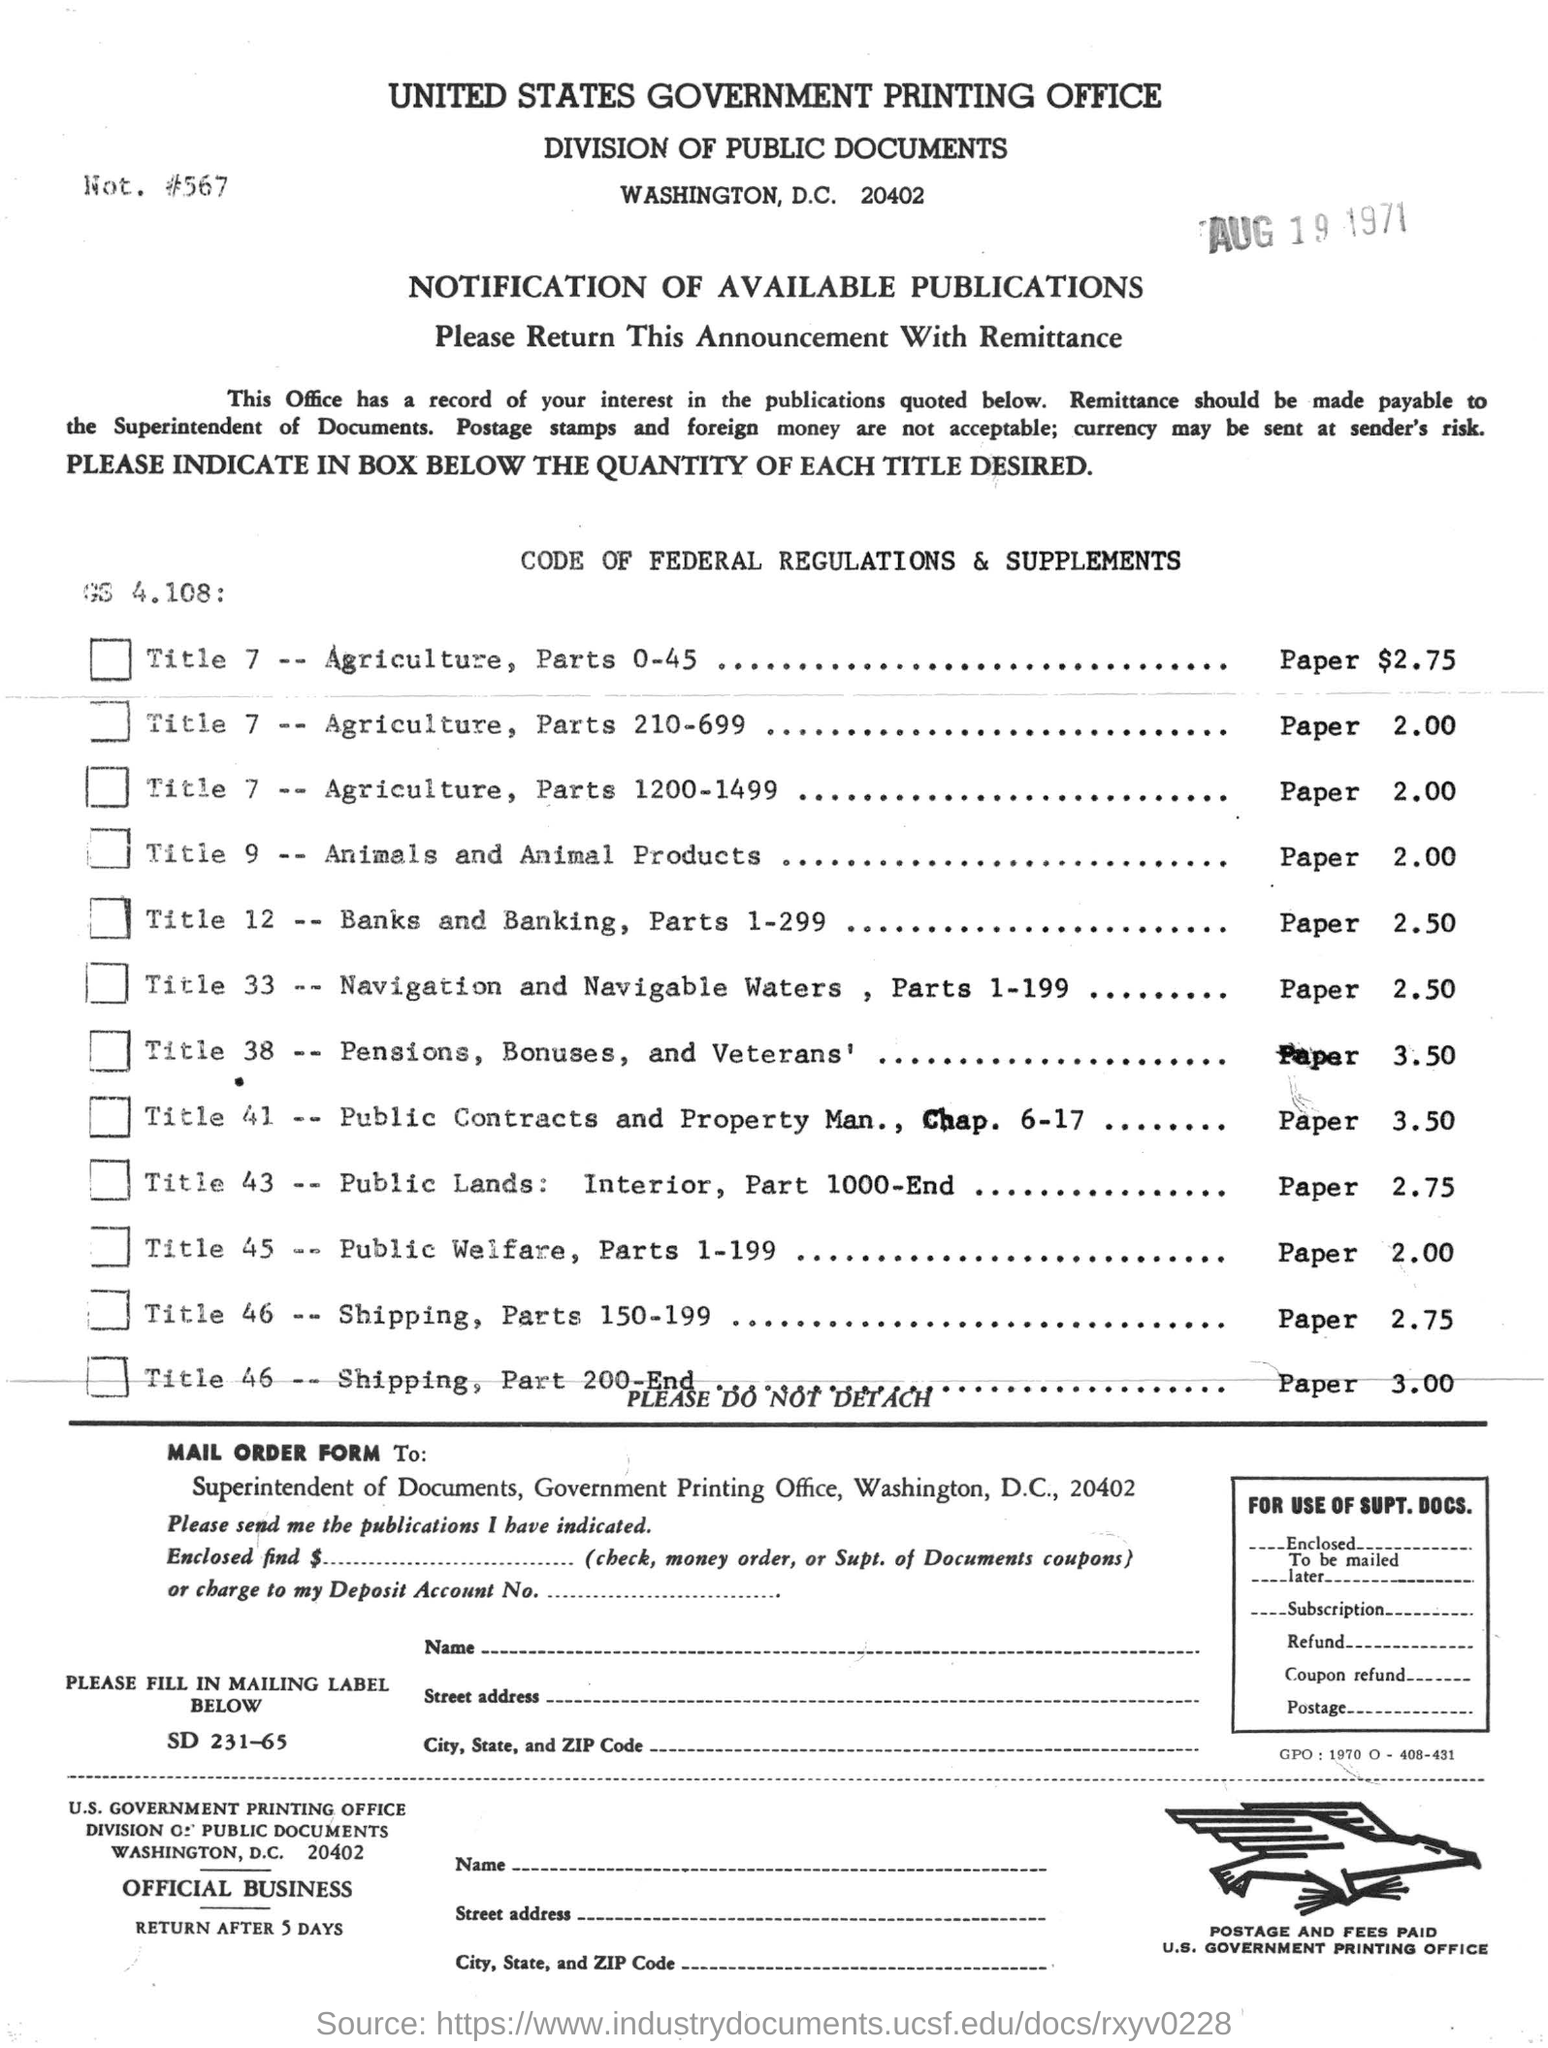Specify some key components in this picture. The title "Animal and animal products sold for paper $2.00" refers to a situation where animals and their byproducts are being sold for a price of $2.00 in paper money. The United States Government Printing Office is located in Washington, D.C. The date-stamp in the document is "August 19, 1971. The United States Government Printing Office is the government printing office in question. 